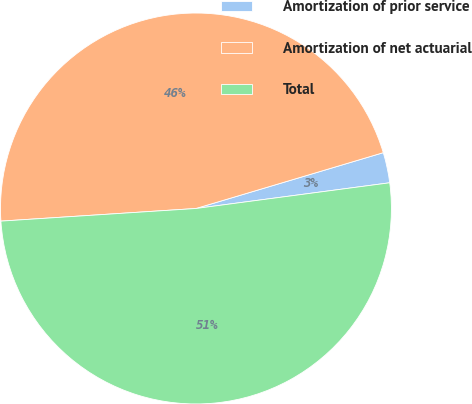Convert chart. <chart><loc_0><loc_0><loc_500><loc_500><pie_chart><fcel>Amortization of prior service<fcel>Amortization of net actuarial<fcel>Total<nl><fcel>2.51%<fcel>46.42%<fcel>51.07%<nl></chart> 